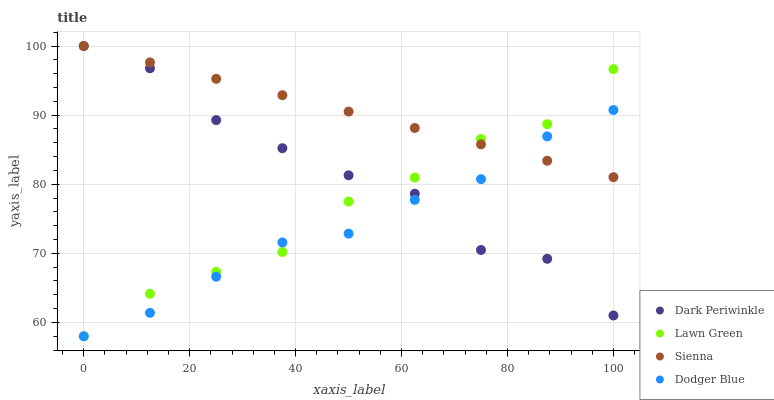Does Dodger Blue have the minimum area under the curve?
Answer yes or no. Yes. Does Sienna have the maximum area under the curve?
Answer yes or no. Yes. Does Lawn Green have the minimum area under the curve?
Answer yes or no. No. Does Lawn Green have the maximum area under the curve?
Answer yes or no. No. Is Sienna the smoothest?
Answer yes or no. Yes. Is Dark Periwinkle the roughest?
Answer yes or no. Yes. Is Lawn Green the smoothest?
Answer yes or no. No. Is Lawn Green the roughest?
Answer yes or no. No. Does Lawn Green have the lowest value?
Answer yes or no. Yes. Does Dark Periwinkle have the lowest value?
Answer yes or no. No. Does Dark Periwinkle have the highest value?
Answer yes or no. Yes. Does Lawn Green have the highest value?
Answer yes or no. No. Does Dark Periwinkle intersect Lawn Green?
Answer yes or no. Yes. Is Dark Periwinkle less than Lawn Green?
Answer yes or no. No. Is Dark Periwinkle greater than Lawn Green?
Answer yes or no. No. 